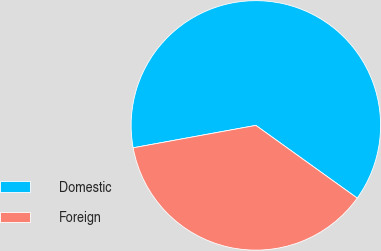<chart> <loc_0><loc_0><loc_500><loc_500><pie_chart><fcel>Domestic<fcel>Foreign<nl><fcel>62.78%<fcel>37.22%<nl></chart> 